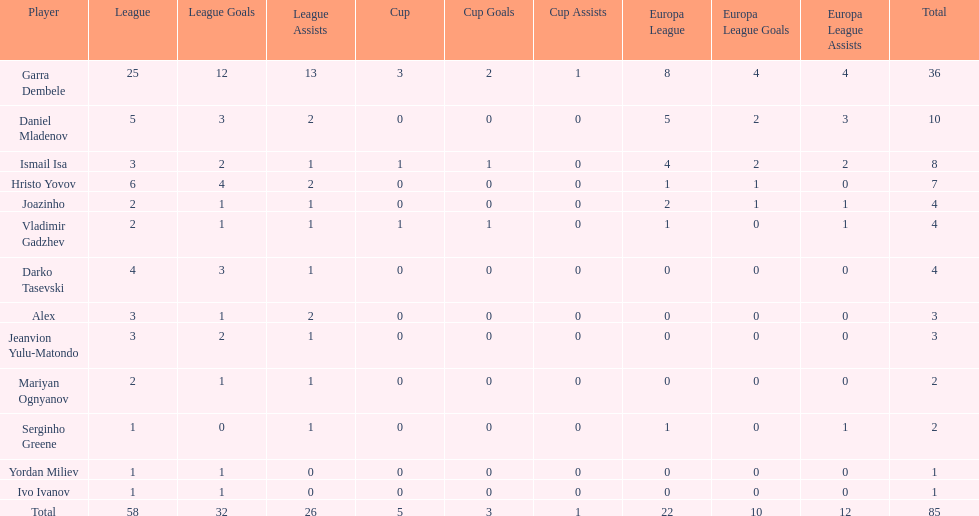Who was the top goalscorer on this team? Garra Dembele. 